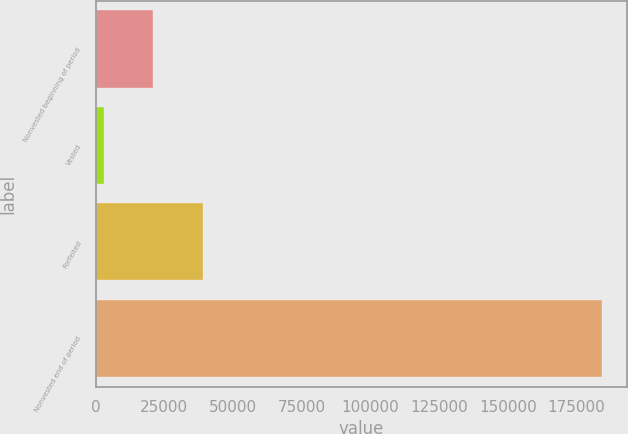<chart> <loc_0><loc_0><loc_500><loc_500><bar_chart><fcel>Nonvested beginning of period<fcel>Vested<fcel>Forfeited<fcel>Nonvested end of period<nl><fcel>21071.9<fcel>2947<fcel>39196.8<fcel>184196<nl></chart> 